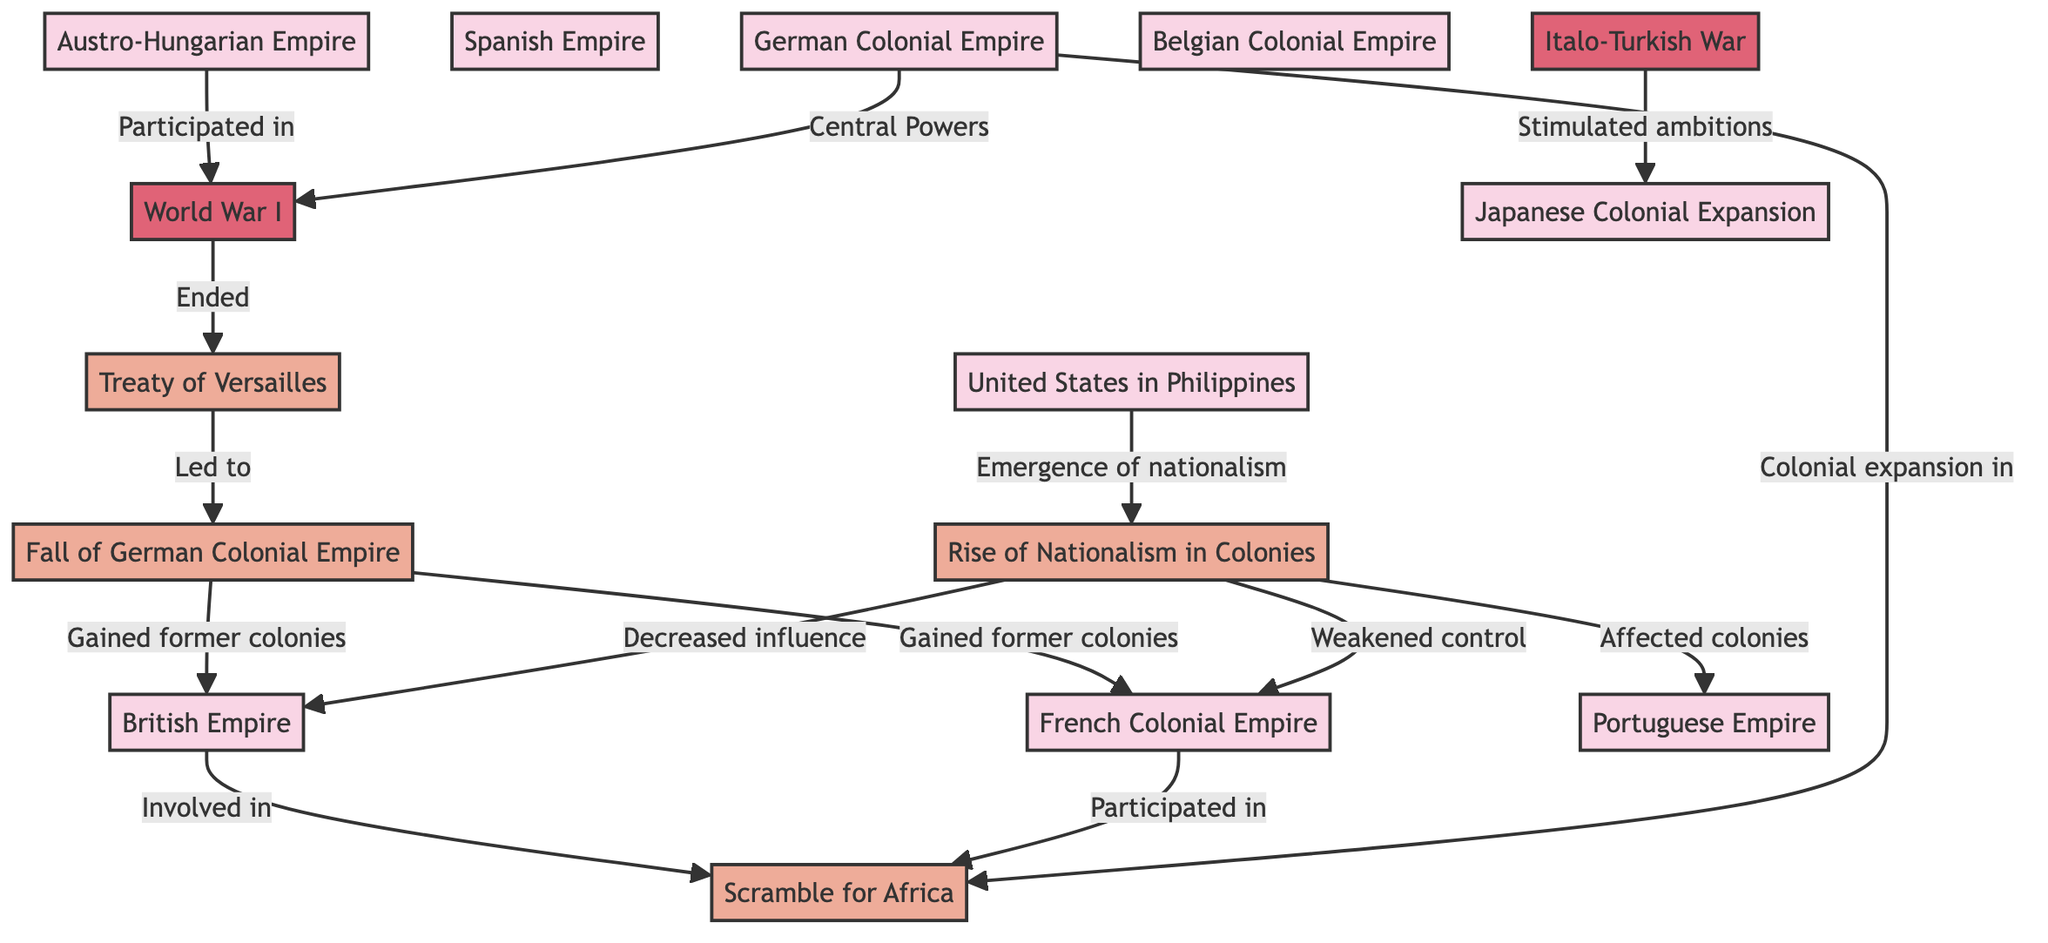What empires are represented in the diagram? The diagram shows seven empires: British Empire, French Colonial Empire, German Colonial Empire, Spanish Empire, Portuguese Empire, Austro-Hungarian Empire, and Belgian Colonial Empire.
Answer: British Empire, French Colonial Empire, German Colonial Empire, Spanish Empire, Portuguese Empire, Austro-Hungarian Empire, Belgian Colonial Empire Which empire participated in the Scramble for Africa? The British Empire and French Colonial Empire are noted as participating in the Scramble for Africa in the diagram.
Answer: British Empire, French Colonial Empire What major event ended in 1918? World War I is the major event that is shown to have ended in 1918 in the diagram.
Answer: World War I How did nationalism in colonies impact the British Empire? Nationalism in colonies decreased the influence of the British Empire, as indicated in the diagram.
Answer: Decreased influence What led to the fall of the German Colonial Empire? The Treaty of Versailles led to the fall of the German Colonial Empire according to the diagram.
Answer: Treaty of Versailles Which empire gained former colonies from the fall of the German Colonial Empire? Both the British Empire and French Colonial Empire gained former colonies from the fall of the German Colonial Empire.
Answer: British Empire, French Colonial Empire What event stimulated Japanese colonial ambitions? The Italo-Turkish War stimulated Japanese colonial ambitions as per the connections in the diagram.
Answer: Italo-Turkish War What was a consequence of the emergence of nationalism in the colonies? The emergence of nationalism in the colonies weakened control over the French Colonial Empire and affected the Portuguese Empire.
Answer: Weakened control, affected colonies How many empires are linked to the Treaty of Versailles? The diagram shows four empires that are connected to the Treaty of Versailles: the British Empire, French Colonial Empire, German Colonial Empire, and Austro-Hungarian Empire.
Answer: Four empires 